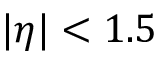Convert formula to latex. <formula><loc_0><loc_0><loc_500><loc_500>| \eta | < 1 . 5</formula> 